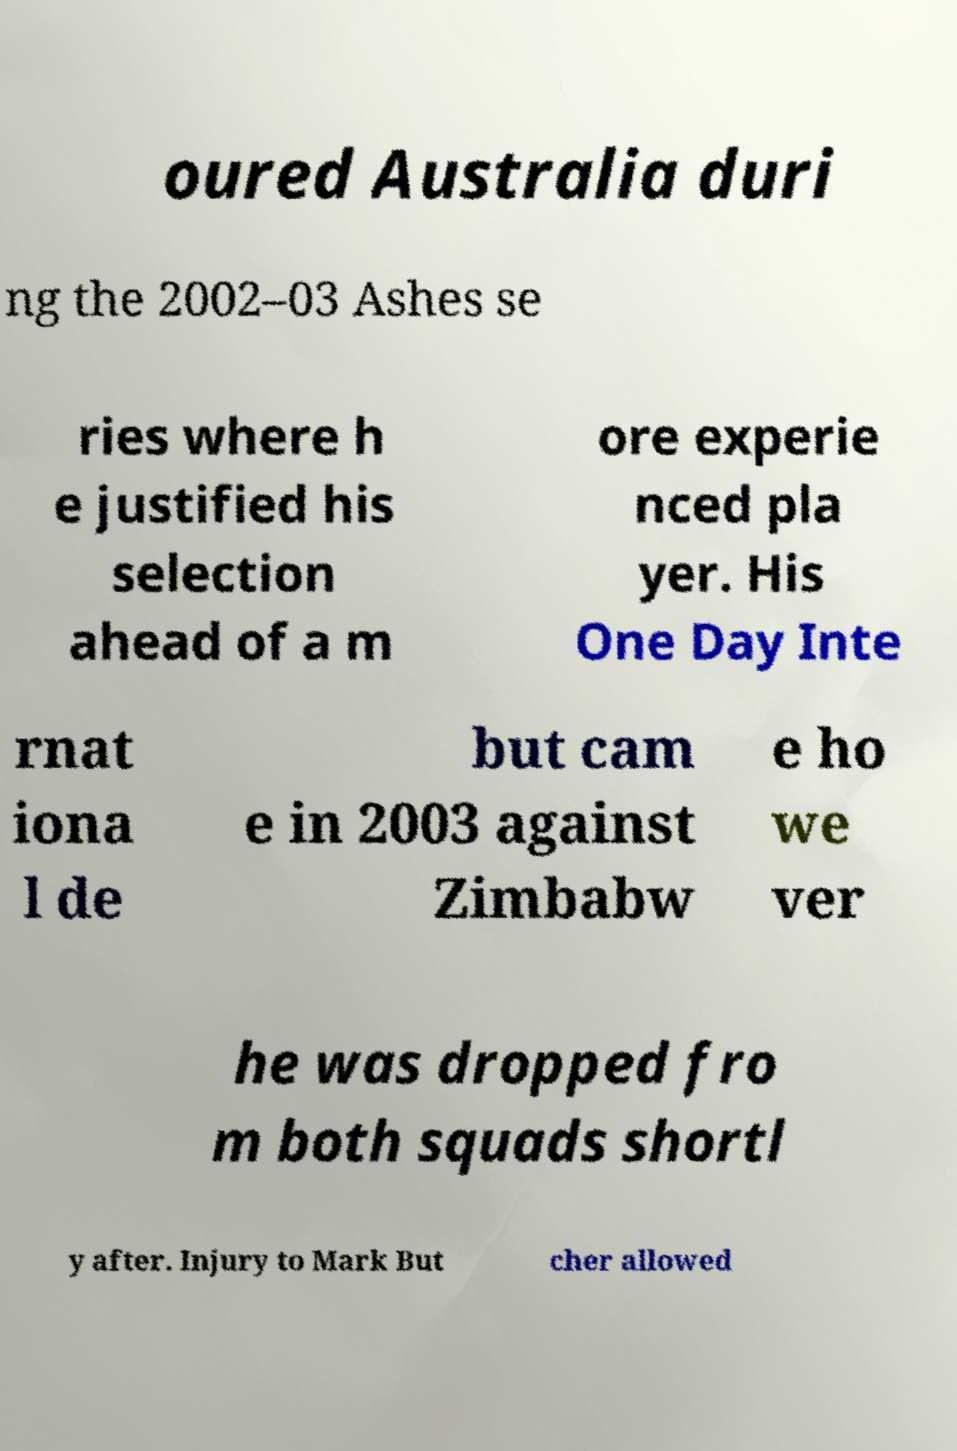What messages or text are displayed in this image? I need them in a readable, typed format. oured Australia duri ng the 2002–03 Ashes se ries where h e justified his selection ahead of a m ore experie nced pla yer. His One Day Inte rnat iona l de but cam e in 2003 against Zimbabw e ho we ver he was dropped fro m both squads shortl y after. Injury to Mark But cher allowed 